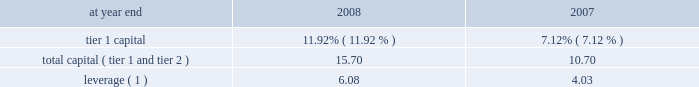Capital resources and liquidity capital resources overview capital is generally generated via earnings from operating businesses .
This is augmented through issuance of common stock , convertible preferred stock , preferred stock , subordinated debt , and equity issued through awards under employee benefit plans .
Capital is used primarily to support assets in the company 2019s businesses and to absorb unexpected market , credit or operational losses .
The company 2019s uses of capital , particularly to pay dividends and repurchase common stock , became severely restricted during the latter half of 2008 .
See 201cthe company , 201d 201cmanagement 2019s discussion and analysis 2013 events in 2008 , 201d 201ctarp and other regulatory programs , 201d 201crisk factors 201d and 201ccommon equity 201d on pages 2 , 9 , 44 , 47 and 95 , respectively .
Citigroup 2019s capital management framework is designed to ensure that citigroup and its principal subsidiaries maintain sufficient capital consistent with the company 2019s risk profile , all applicable regulatory standards and guidelines , and external rating agency considerations .
The capital management process is centrally overseen by senior management and is reviewed at the consolidated , legal entity , and country level .
Senior management oversees the capital management process of citigroup and its principal subsidiaries mainly through citigroup 2019s finance and asset and liability committee ( finalco ) .
The committee is composed of the senior-most management of citigroup for the purpose of engaging management in decision-making and related discussions on capital and liquidity items .
Among other things , the committee 2019s responsibilities include : determining the financial structure of citigroup and its principal subsidiaries ; ensuring that citigroup and its regulated entities are adequately capitalized ; determining appropriate asset levels and return hurdles for citigroup and individual businesses ; reviewing the funding and capital markets plan for citigroup ; and monitoring interest-rate risk , corporate and bank liquidity , the impact of currency translation on non-u.s .
Earnings and capital .
The finalco has established capital targets for citigroup and for significant subsidiaries .
At december 31 , 2008 , these targets exceeded the regulatory standards .
Common and preferred stock issuances as discussed under 201cevents in 2008 201d on page 9 , during 2008 , the company issued $ 45 billion in preferred stock and warrants under tarp , $ 12.5 billion of convertible preferred stock in a private offering , $ 11.7 billion of non-convertible preferred stock in public offerings , $ 3.2 billion of convertible preferred stock in public offerings , and $ 4.9 billion of common stock in public offerings .
On january 23 , 2009 , pursuant to our prior agreement with the purchasers of the $ 12.5 billion convertible preferred stock issued in the private offering , the conversion price was reset from $ 31.62 per share to $ 26.35 per share .
The reset will result in citigroup 2019s issuing approximately 79 million additional common shares if converted .
There will be no impact to net income , total stockholders 2019 equity or capital ratios due to the reset .
However , the reset will result in a reclassification from retained earnings to additional paid-in capital of $ 1.2 billion to reflect the benefit of the reset to the preferred stockholders .
Capital ratios citigroup is subject to risk-based capital ratio guidelines issued by the federal reserve board ( frb ) .
Capital adequacy is measured via two risk- based ratios , tier 1 and total capital ( tier 1 + tier 2 capital ) .
Tier 1 capital is considered core capital while total capital also includes other items such as subordinated debt and loan loss reserves .
Both measures of capital are stated as a percentage of risk-weighted assets .
Risk-weighted assets are measured primarily on their perceived credit risk and include certain off-balance-sheet exposures , such as unfunded loan commitments and letters of credit , and the notional amounts of derivative and foreign- exchange contracts .
Citigroup is also subject to the leverage ratio requirement , a non-risk-based asset ratio , which is defined as tier 1 capital as a percentage of adjusted average assets .
To be 201cwell capitalized 201d under federal bank regulatory agency definitions , a bank holding company must have a tier 1 capital ratio of at least 6% ( 6 % ) , a total capital ratio of at least 10% ( 10 % ) , and a leverage ratio of at least 3% ( 3 % ) , and not be subject to an frb directive to maintain higher capital levels .
As noted in the table , citigroup maintained a 201cwell capitalized 201d position during both 2008 and 2007 .
Citigroup regulatory capital ratios at year end 2008 2007 .
Leverage ( 1 ) 6.08 4.03 ( 1 ) tier 1 capital divided by adjusted average assets .
Events occurring during 2008 , including the transactions with the u.s .
Government , affected citigroup 2019s capital ratios , and any additional u.s .
Government financial involvement with the company could further impact the company 2019s capital ratios .
In addition , future operations will affect capital levels , and changes that the fasb has proposed regarding off-balance-sheet assets , consolidation and sale treatment could also have an impact on capital ratios .
See also note 23 to the consolidated financial statements on page 175 , including 201cfunding liquidity facilities and subordinate interests . 201d .
What was the percentage discount given in the reset of convertible preferred stock issued in the private offering ? 
Computations: ((31.62 - 26.35) / 31.62)
Answer: 0.16667. Capital resources and liquidity capital resources overview capital is generally generated via earnings from operating businesses .
This is augmented through issuance of common stock , convertible preferred stock , preferred stock , subordinated debt , and equity issued through awards under employee benefit plans .
Capital is used primarily to support assets in the company 2019s businesses and to absorb unexpected market , credit or operational losses .
The company 2019s uses of capital , particularly to pay dividends and repurchase common stock , became severely restricted during the latter half of 2008 .
See 201cthe company , 201d 201cmanagement 2019s discussion and analysis 2013 events in 2008 , 201d 201ctarp and other regulatory programs , 201d 201crisk factors 201d and 201ccommon equity 201d on pages 2 , 9 , 44 , 47 and 95 , respectively .
Citigroup 2019s capital management framework is designed to ensure that citigroup and its principal subsidiaries maintain sufficient capital consistent with the company 2019s risk profile , all applicable regulatory standards and guidelines , and external rating agency considerations .
The capital management process is centrally overseen by senior management and is reviewed at the consolidated , legal entity , and country level .
Senior management oversees the capital management process of citigroup and its principal subsidiaries mainly through citigroup 2019s finance and asset and liability committee ( finalco ) .
The committee is composed of the senior-most management of citigroup for the purpose of engaging management in decision-making and related discussions on capital and liquidity items .
Among other things , the committee 2019s responsibilities include : determining the financial structure of citigroup and its principal subsidiaries ; ensuring that citigroup and its regulated entities are adequately capitalized ; determining appropriate asset levels and return hurdles for citigroup and individual businesses ; reviewing the funding and capital markets plan for citigroup ; and monitoring interest-rate risk , corporate and bank liquidity , the impact of currency translation on non-u.s .
Earnings and capital .
The finalco has established capital targets for citigroup and for significant subsidiaries .
At december 31 , 2008 , these targets exceeded the regulatory standards .
Common and preferred stock issuances as discussed under 201cevents in 2008 201d on page 9 , during 2008 , the company issued $ 45 billion in preferred stock and warrants under tarp , $ 12.5 billion of convertible preferred stock in a private offering , $ 11.7 billion of non-convertible preferred stock in public offerings , $ 3.2 billion of convertible preferred stock in public offerings , and $ 4.9 billion of common stock in public offerings .
On january 23 , 2009 , pursuant to our prior agreement with the purchasers of the $ 12.5 billion convertible preferred stock issued in the private offering , the conversion price was reset from $ 31.62 per share to $ 26.35 per share .
The reset will result in citigroup 2019s issuing approximately 79 million additional common shares if converted .
There will be no impact to net income , total stockholders 2019 equity or capital ratios due to the reset .
However , the reset will result in a reclassification from retained earnings to additional paid-in capital of $ 1.2 billion to reflect the benefit of the reset to the preferred stockholders .
Capital ratios citigroup is subject to risk-based capital ratio guidelines issued by the federal reserve board ( frb ) .
Capital adequacy is measured via two risk- based ratios , tier 1 and total capital ( tier 1 + tier 2 capital ) .
Tier 1 capital is considered core capital while total capital also includes other items such as subordinated debt and loan loss reserves .
Both measures of capital are stated as a percentage of risk-weighted assets .
Risk-weighted assets are measured primarily on their perceived credit risk and include certain off-balance-sheet exposures , such as unfunded loan commitments and letters of credit , and the notional amounts of derivative and foreign- exchange contracts .
Citigroup is also subject to the leverage ratio requirement , a non-risk-based asset ratio , which is defined as tier 1 capital as a percentage of adjusted average assets .
To be 201cwell capitalized 201d under federal bank regulatory agency definitions , a bank holding company must have a tier 1 capital ratio of at least 6% ( 6 % ) , a total capital ratio of at least 10% ( 10 % ) , and a leverage ratio of at least 3% ( 3 % ) , and not be subject to an frb directive to maintain higher capital levels .
As noted in the table , citigroup maintained a 201cwell capitalized 201d position during both 2008 and 2007 .
Citigroup regulatory capital ratios at year end 2008 2007 .
Leverage ( 1 ) 6.08 4.03 ( 1 ) tier 1 capital divided by adjusted average assets .
Events occurring during 2008 , including the transactions with the u.s .
Government , affected citigroup 2019s capital ratios , and any additional u.s .
Government financial involvement with the company could further impact the company 2019s capital ratios .
In addition , future operations will affect capital levels , and changes that the fasb has proposed regarding off-balance-sheet assets , consolidation and sale treatment could also have an impact on capital ratios .
See also note 23 to the consolidated financial statements on page 175 , including 201cfunding liquidity facilities and subordinate interests . 201d .
What was the change in tier 1 capital % (  % ) from 2007 to 2008? 
Computations: (11.92% - 7.12%)
Answer: 0.048. 